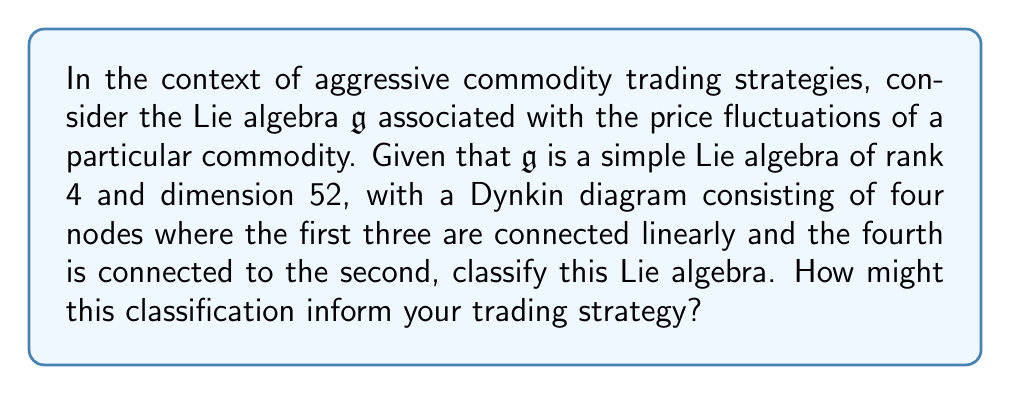Give your solution to this math problem. To classify the simple Lie algebra $\mathfrak{g}$, we need to analyze the given information and compare it with the known classifications of simple Lie algebras:

1. Rank: The algebra has rank 4, meaning it has 4 simple roots.

2. Dimension: The dimension is 52.

3. Dynkin diagram: 
   [asy]
   unitsize(1cm);
   dotforsix(0,0); dotforsix(1,0); dotforsix(2,0); dotforsix(1,1);
   draw((0,0)--(2,0));
   draw((1,0)--(1,1));
   [/asy]

This Dynkin diagram corresponds to the $F_4$ exceptional Lie algebra.

To confirm this classification:

1. The rank of $F_4$ is indeed 4.

2. The dimension of $F_4$ is calculated as:
   $\dim(F_4) = 4 \cdot 2 + 24 = 52$
   where 4 is the rank (number of simple roots) and 24 is the number of positive roots.

3. The Dynkin diagram matches the one given for $F_4$.

Therefore, we can confidently classify $\mathfrak{g}$ as the $F_4$ exceptional Lie algebra.

In terms of trading strategy, the $F_4$ algebra can be relevant in several ways:

1. Symmetry analysis: $F_4$ has a rich symmetry structure that could be used to model complex relationships between different commodities or market factors.

2. Risk management: The root system of $F_4$ could be used to develop sophisticated risk metrics that account for multiple interrelated factors.

3. Predictive modeling: The structure of $F_4$ could inform the development of predictive models that capture non-linear relationships in commodity price movements.

4. Portfolio optimization: The symmetries in $F_4$ could be leveraged to design balanced portfolios that are robust against various market conditions.

5. Algorithmic trading: The algebraic structure could be used to design trading algorithms that exploit subtle market inefficiencies.

By understanding and utilizing the properties of the $F_4$ Lie algebra, a trader could potentially develop more sophisticated and effective aggressive trading strategies in the commodity market.
Answer: The simple Lie algebra $\mathfrak{g}$ is classified as the exceptional Lie algebra $F_4$. This classification can inform aggressive commodity trading strategies through symmetry analysis, enhanced risk management, advanced predictive modeling, sophisticated portfolio optimization, and development of complex algorithmic trading systems. 